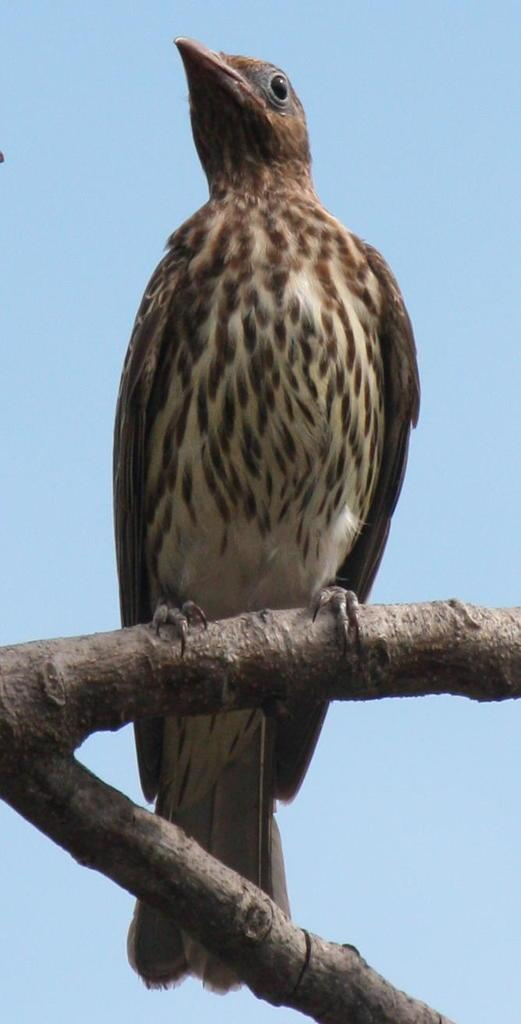What type of animal can be seen in the image? There is a bird in the image. Where is the bird located? The bird is standing on a branch of a tree. What can be seen in the background of the image? There is a sky visible in the background of the image. What type of reward is the bird holding in the image? There is no reward present in the image; the bird is simply standing on a branch of a tree. 